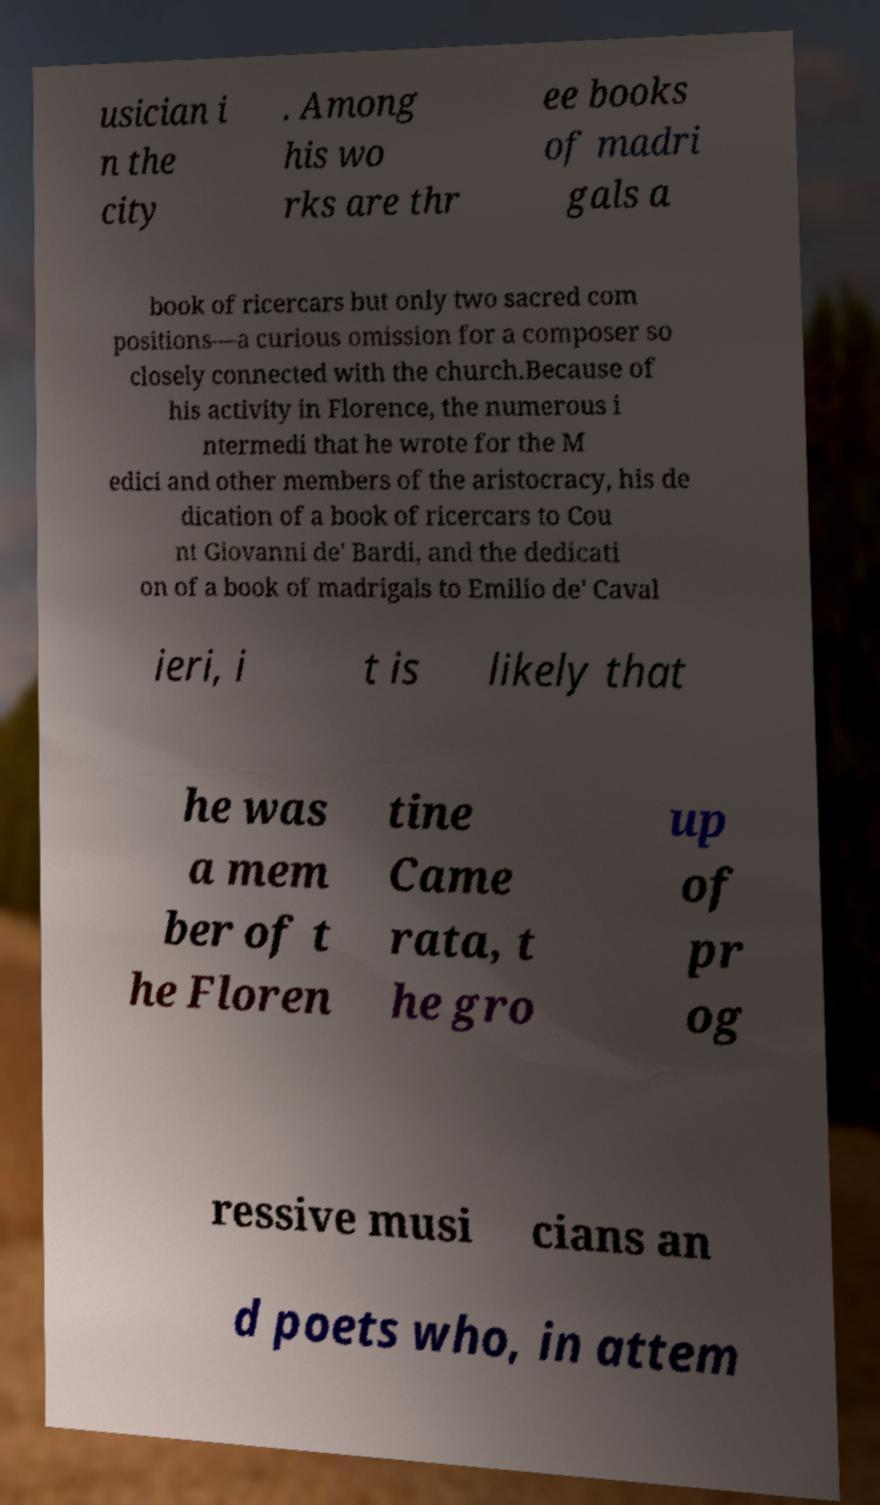Could you extract and type out the text from this image? usician i n the city . Among his wo rks are thr ee books of madri gals a book of ricercars but only two sacred com positions—a curious omission for a composer so closely connected with the church.Because of his activity in Florence, the numerous i ntermedi that he wrote for the M edici and other members of the aristocracy, his de dication of a book of ricercars to Cou nt Giovanni de' Bardi, and the dedicati on of a book of madrigals to Emilio de' Caval ieri, i t is likely that he was a mem ber of t he Floren tine Came rata, t he gro up of pr og ressive musi cians an d poets who, in attem 